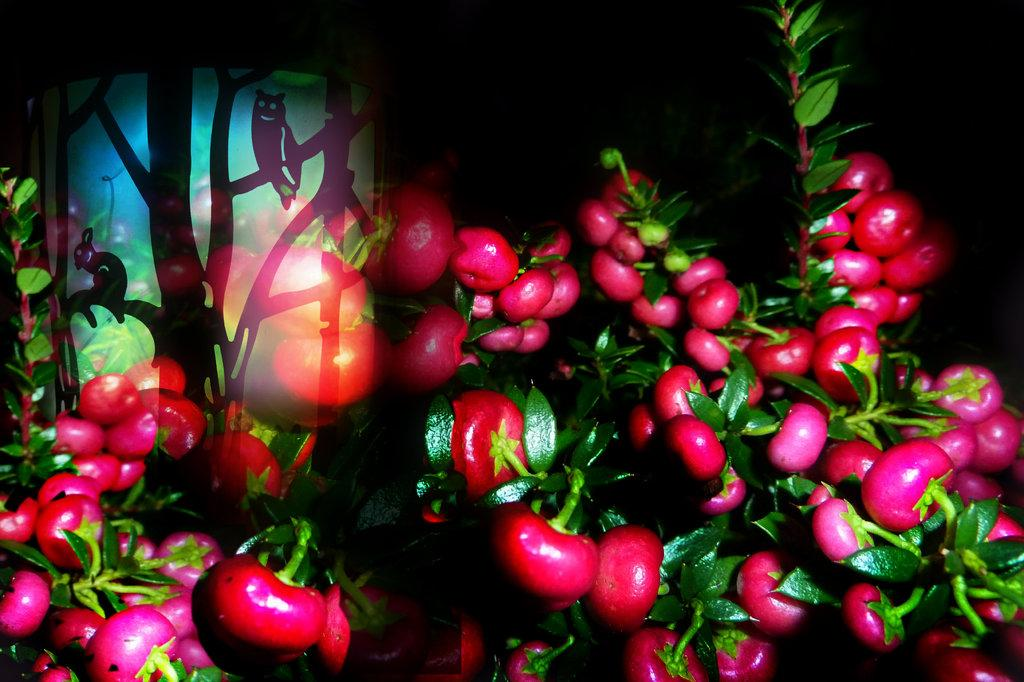What color are the fruits in the image? The fruits in the image are pink. Where are the fruits located in the image? The fruits are visible on plants. What type of knife is used to start cutting the fruits in the image? There is no knife present in the image, and the fruits are not being cut. 